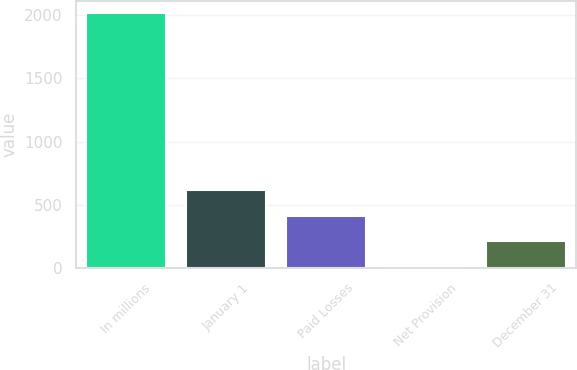<chart> <loc_0><loc_0><loc_500><loc_500><bar_chart><fcel>In millions<fcel>January 1<fcel>Paid Losses<fcel>Net Provision<fcel>December 31<nl><fcel>2013<fcel>615.1<fcel>415.4<fcel>16<fcel>215.7<nl></chart> 